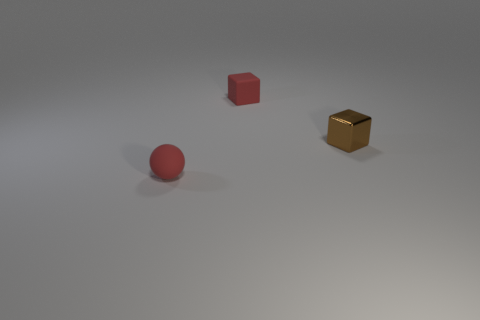There is a thing that is both behind the small red ball and left of the tiny brown thing; what is its shape? cube 